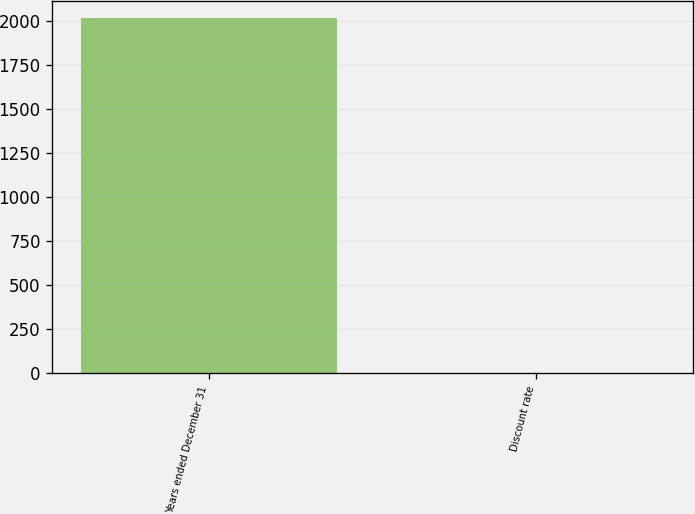Convert chart to OTSL. <chart><loc_0><loc_0><loc_500><loc_500><bar_chart><fcel>Years ended December 31<fcel>Discount rate<nl><fcel>2013<fcel>4.32<nl></chart> 